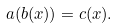<formula> <loc_0><loc_0><loc_500><loc_500>a ( b ( x ) ) = c ( x ) .</formula> 